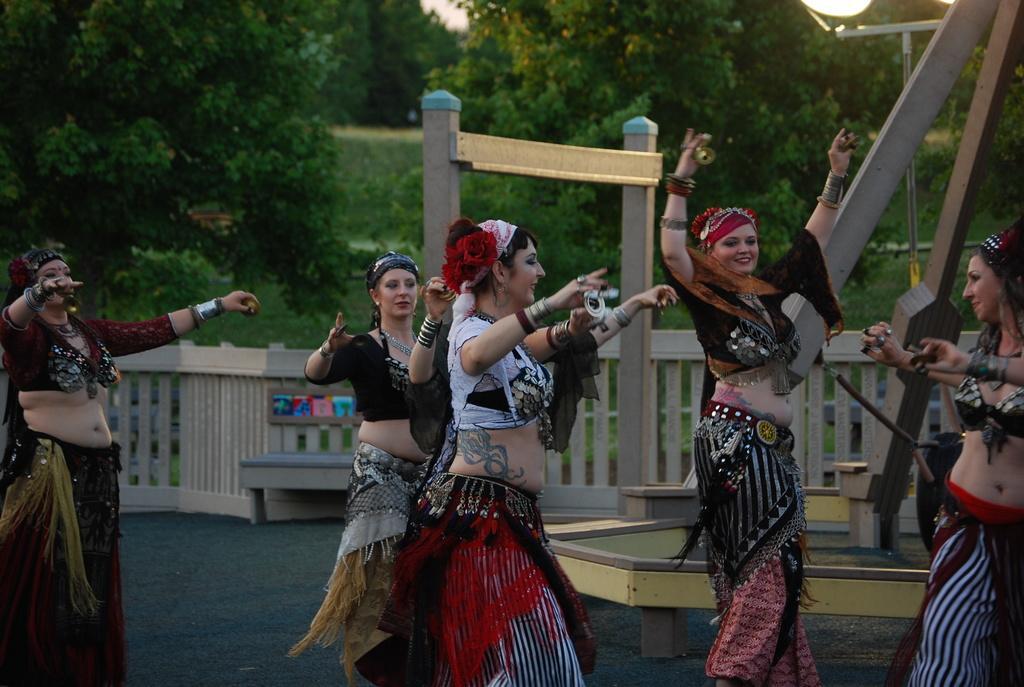Can you describe this image briefly? In the picture I can see these women wearing different costumes are dancing on the ground. In the background, I can see the fence, poles, light poles, grass and trees. 